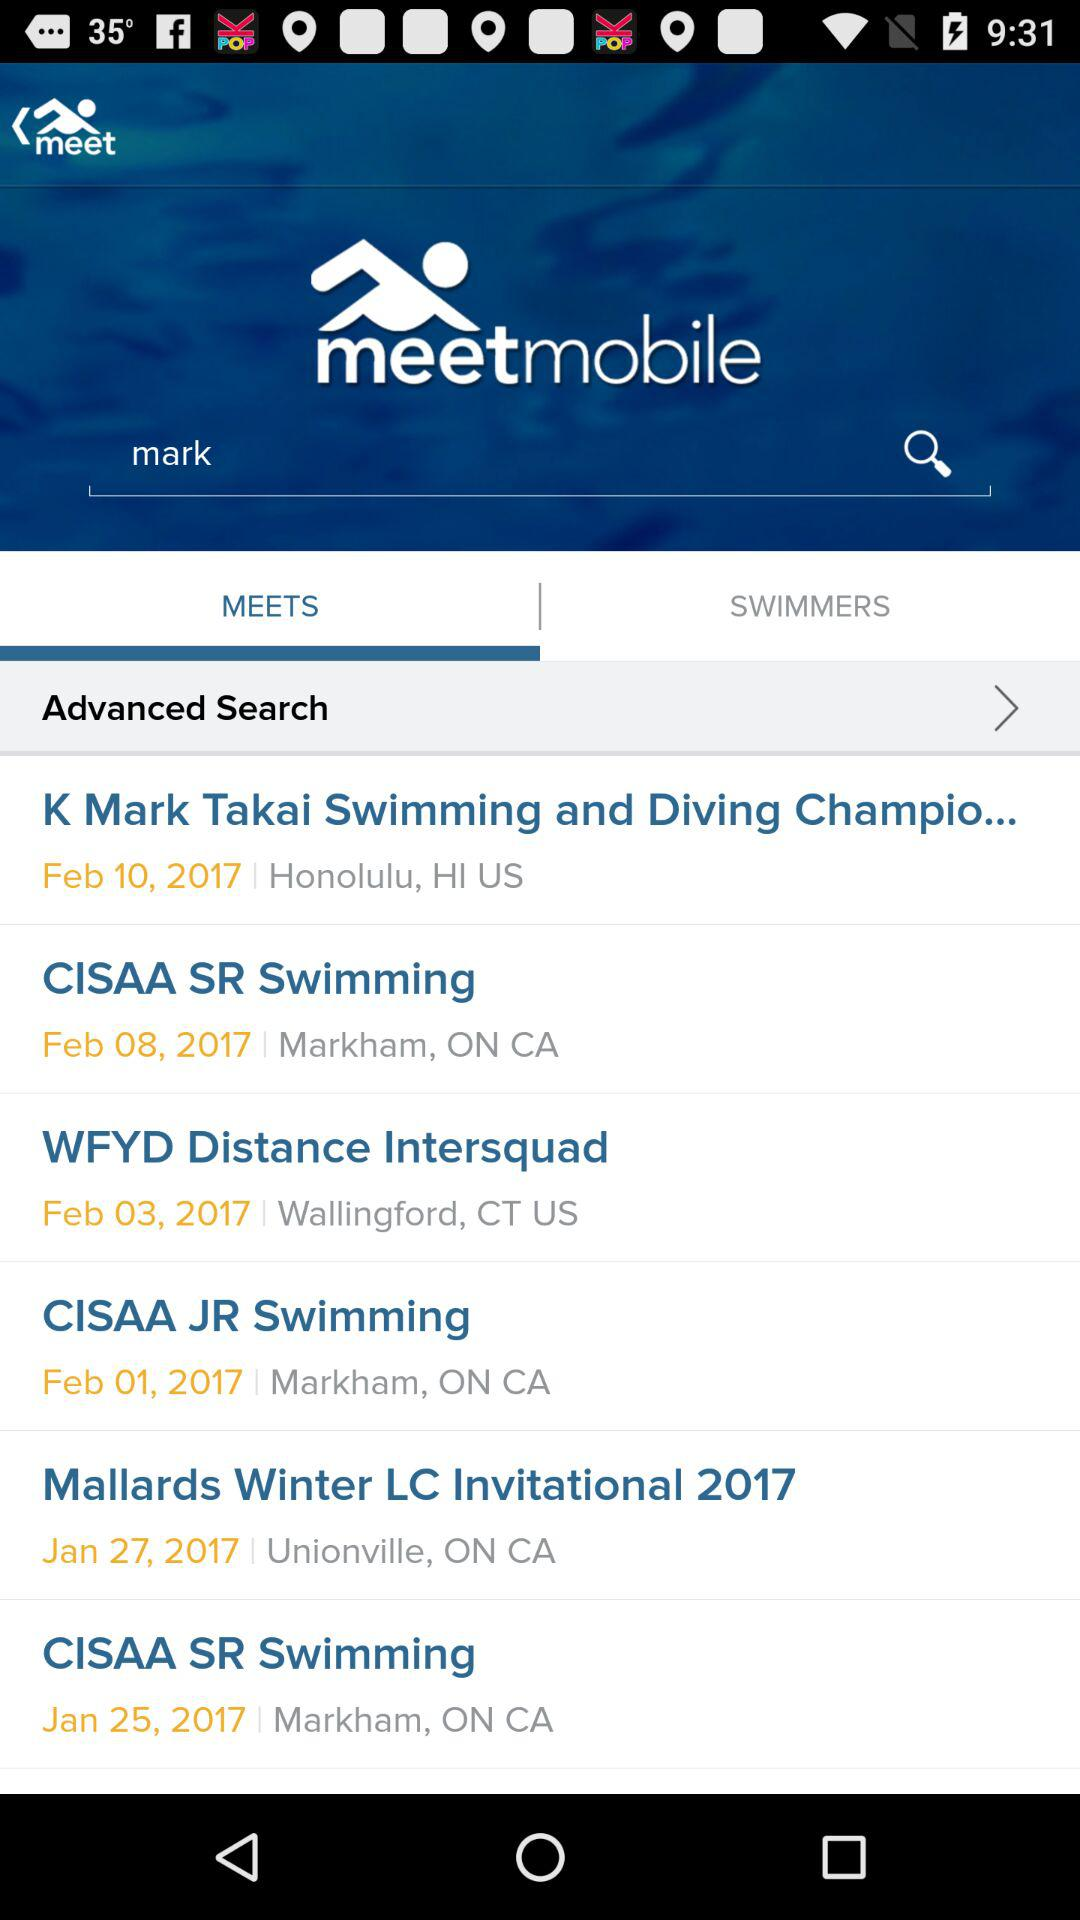What is the location of "CISAA SR Swimming"? The location is Markham, Ontario, Canada. 